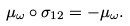Convert formula to latex. <formula><loc_0><loc_0><loc_500><loc_500>\mu _ { \omega } \circ \sigma _ { 1 2 } = - \mu _ { \omega } .</formula> 